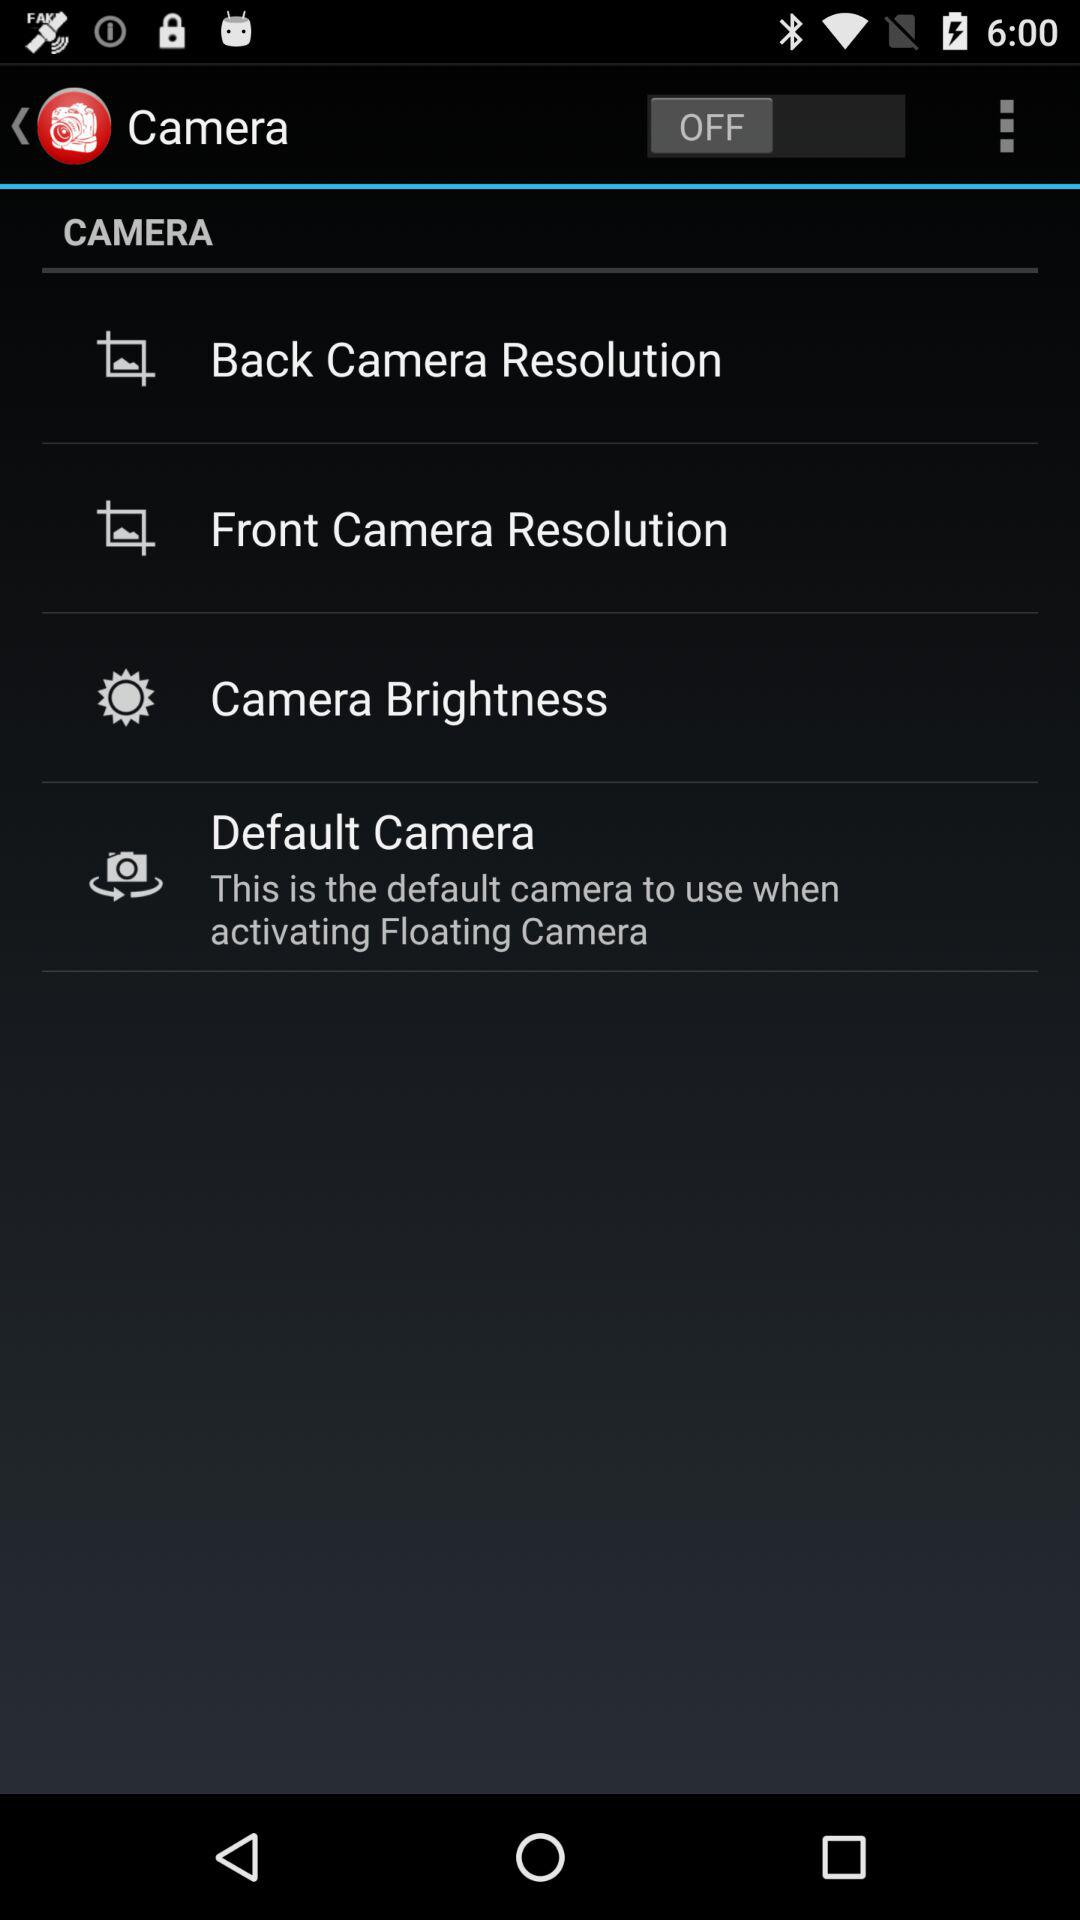What is the status of the camera? The status is off. 